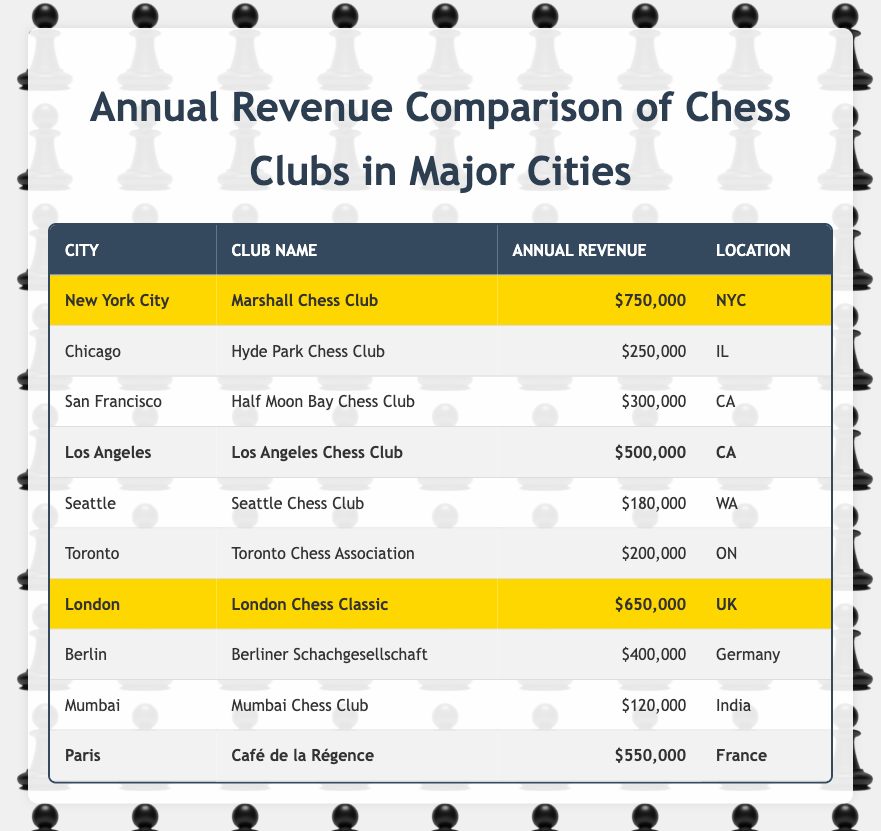What is the annual revenue of the Marshall Chess Club? The table lists the Marshall Chess Club under New York City with an annual revenue of $750,000.
Answer: $750,000 Which chess club has the highest annual revenue? By examining the annual revenue values, the Marshall Chess Club in New York City has the highest revenue at $750,000.
Answer: Marshall Chess Club What is the total annual revenue of the highlighted clubs? The highlighted clubs are Marshall Chess Club ($750,000), Los Angeles Chess Club ($500,000), London Chess Classic ($650,000), and Café de la Régence ($550,000). Adding these gives $750,000 + $500,000 + $650,000 + $550,000 = $2,450,000.
Answer: $2,450,000 Is the annual revenue of the Chicago chess club higher than $200,000? The annual revenue of the Hyde Park Chess Club in Chicago is $250,000, which is higher than $200,000.
Answer: Yes What is the average annual revenue of the chess clubs listed? First, we calculate the total revenue: $750,000 + $250,000 + $300,000 + $500,000 + $180,000 + $200,000 + $650,000 + $400,000 + $120,000 + $550,000 = $3,000,000. With 10 clubs, the average is $3,000,000 / 10 = $300,000.
Answer: $300,000 Which cities have chess clubs with annual revenues above $500,000? From the table, only New York City (Marshall Chess Club for $750,000) and London (London Chess Classic for $650,000) have annual revenues exceeding $500,000.
Answer: New York City and London How many chess clubs have annual revenues less than $200,000? Only the Mumbai Chess Club has an annual revenue of $120,000, which is less than $200,000. Therefore, there is 1 such club.
Answer: 1 What is the difference in annual revenue between the Los Angeles Chess Club and the London Chess Classic? The Los Angeles Chess Club has an annual revenue of $500,000 and the London Chess Classic has $650,000. The difference is $650,000 - $500,000 = $150,000.
Answer: $150,000 If we combine the revenues of the chess clubs in CA, what would that total be? The clubs in CA are Half Moon Bay Chess Club ($300,000) and Los Angeles Chess Club ($500,000). Their total revenue is $300,000 + $500,000 = $800,000.
Answer: $800,000 Are there any chess clubs that have revenues between $200,000 and $400,000? Yes, the Half Moon Bay Chess Club ($300,000) and Berliner Schachgesellschaft ($400,000) both have revenues that fit within that range.
Answer: Yes 